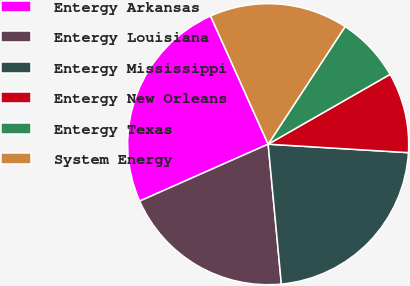<chart> <loc_0><loc_0><loc_500><loc_500><pie_chart><fcel>Entergy Arkansas<fcel>Entergy Louisiana<fcel>Entergy Mississippi<fcel>Entergy New Orleans<fcel>Entergy Texas<fcel>System Energy<nl><fcel>24.92%<fcel>19.86%<fcel>22.54%<fcel>9.24%<fcel>7.5%<fcel>15.94%<nl></chart> 